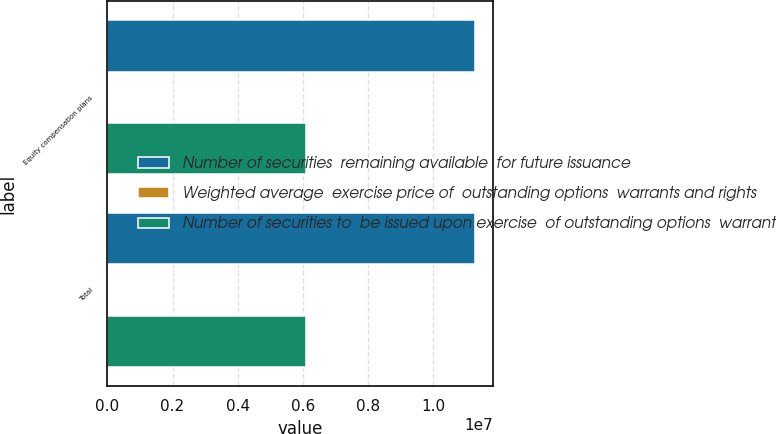<chart> <loc_0><loc_0><loc_500><loc_500><stacked_bar_chart><ecel><fcel>Equity compensation plans<fcel>Total<nl><fcel>Number of securities  remaining available  for future issuance<fcel>1.12799e+07<fcel>1.12799e+07<nl><fcel>Weighted average  exercise price of  outstanding options  warrants and rights<fcel>19.72<fcel>19.72<nl><fcel>Number of securities to  be issued upon exercise  of outstanding options  warrants and rights<fcel>6.10338e+06<fcel>6.10338e+06<nl></chart> 